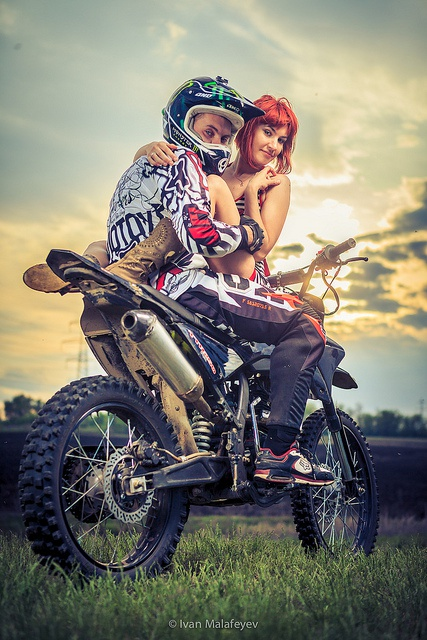Describe the objects in this image and their specific colors. I can see motorcycle in gray, black, navy, and tan tones, people in gray, navy, black, and lightgray tones, and people in gray, brown, and tan tones in this image. 